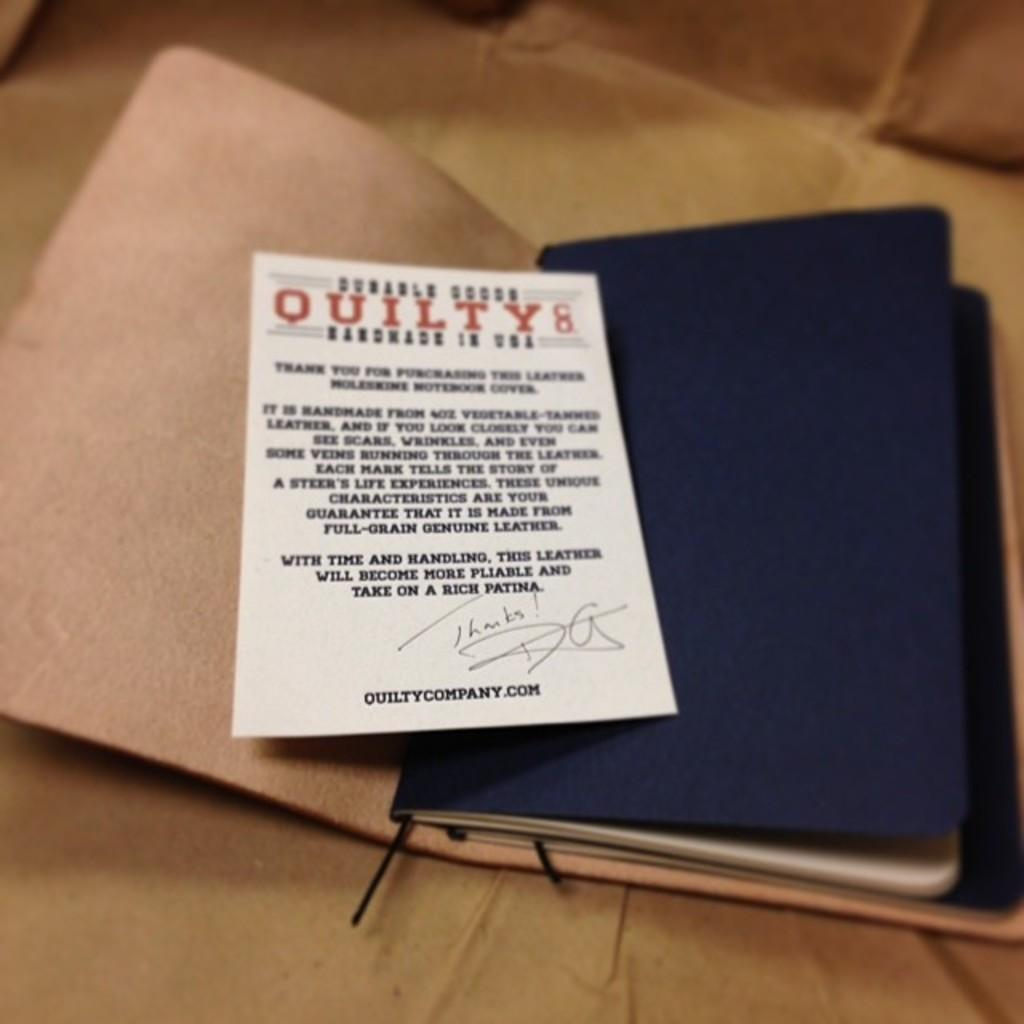<image>
Share a concise interpretation of the image provided. An information card included with a product is from the quiltycompany.com. 